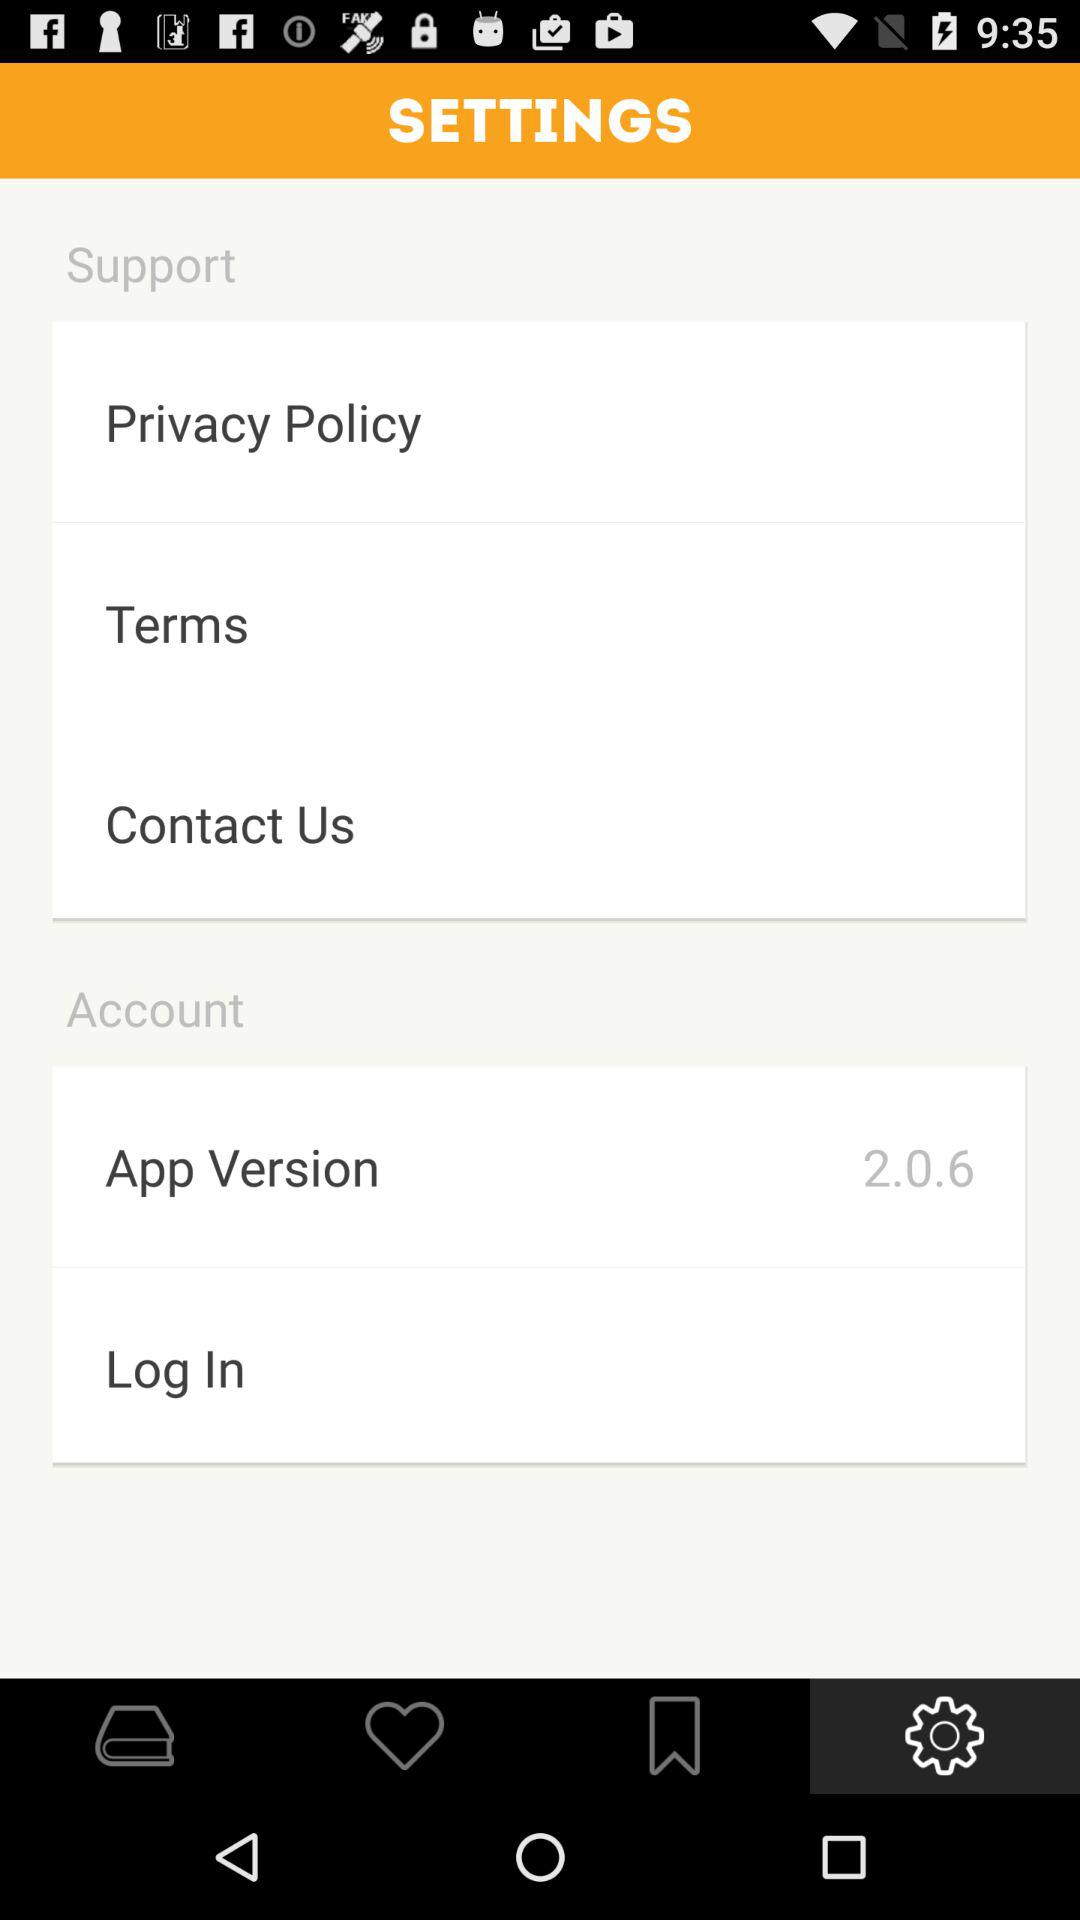How do you contact support?
When the provided information is insufficient, respond with <no answer>. <no answer> 